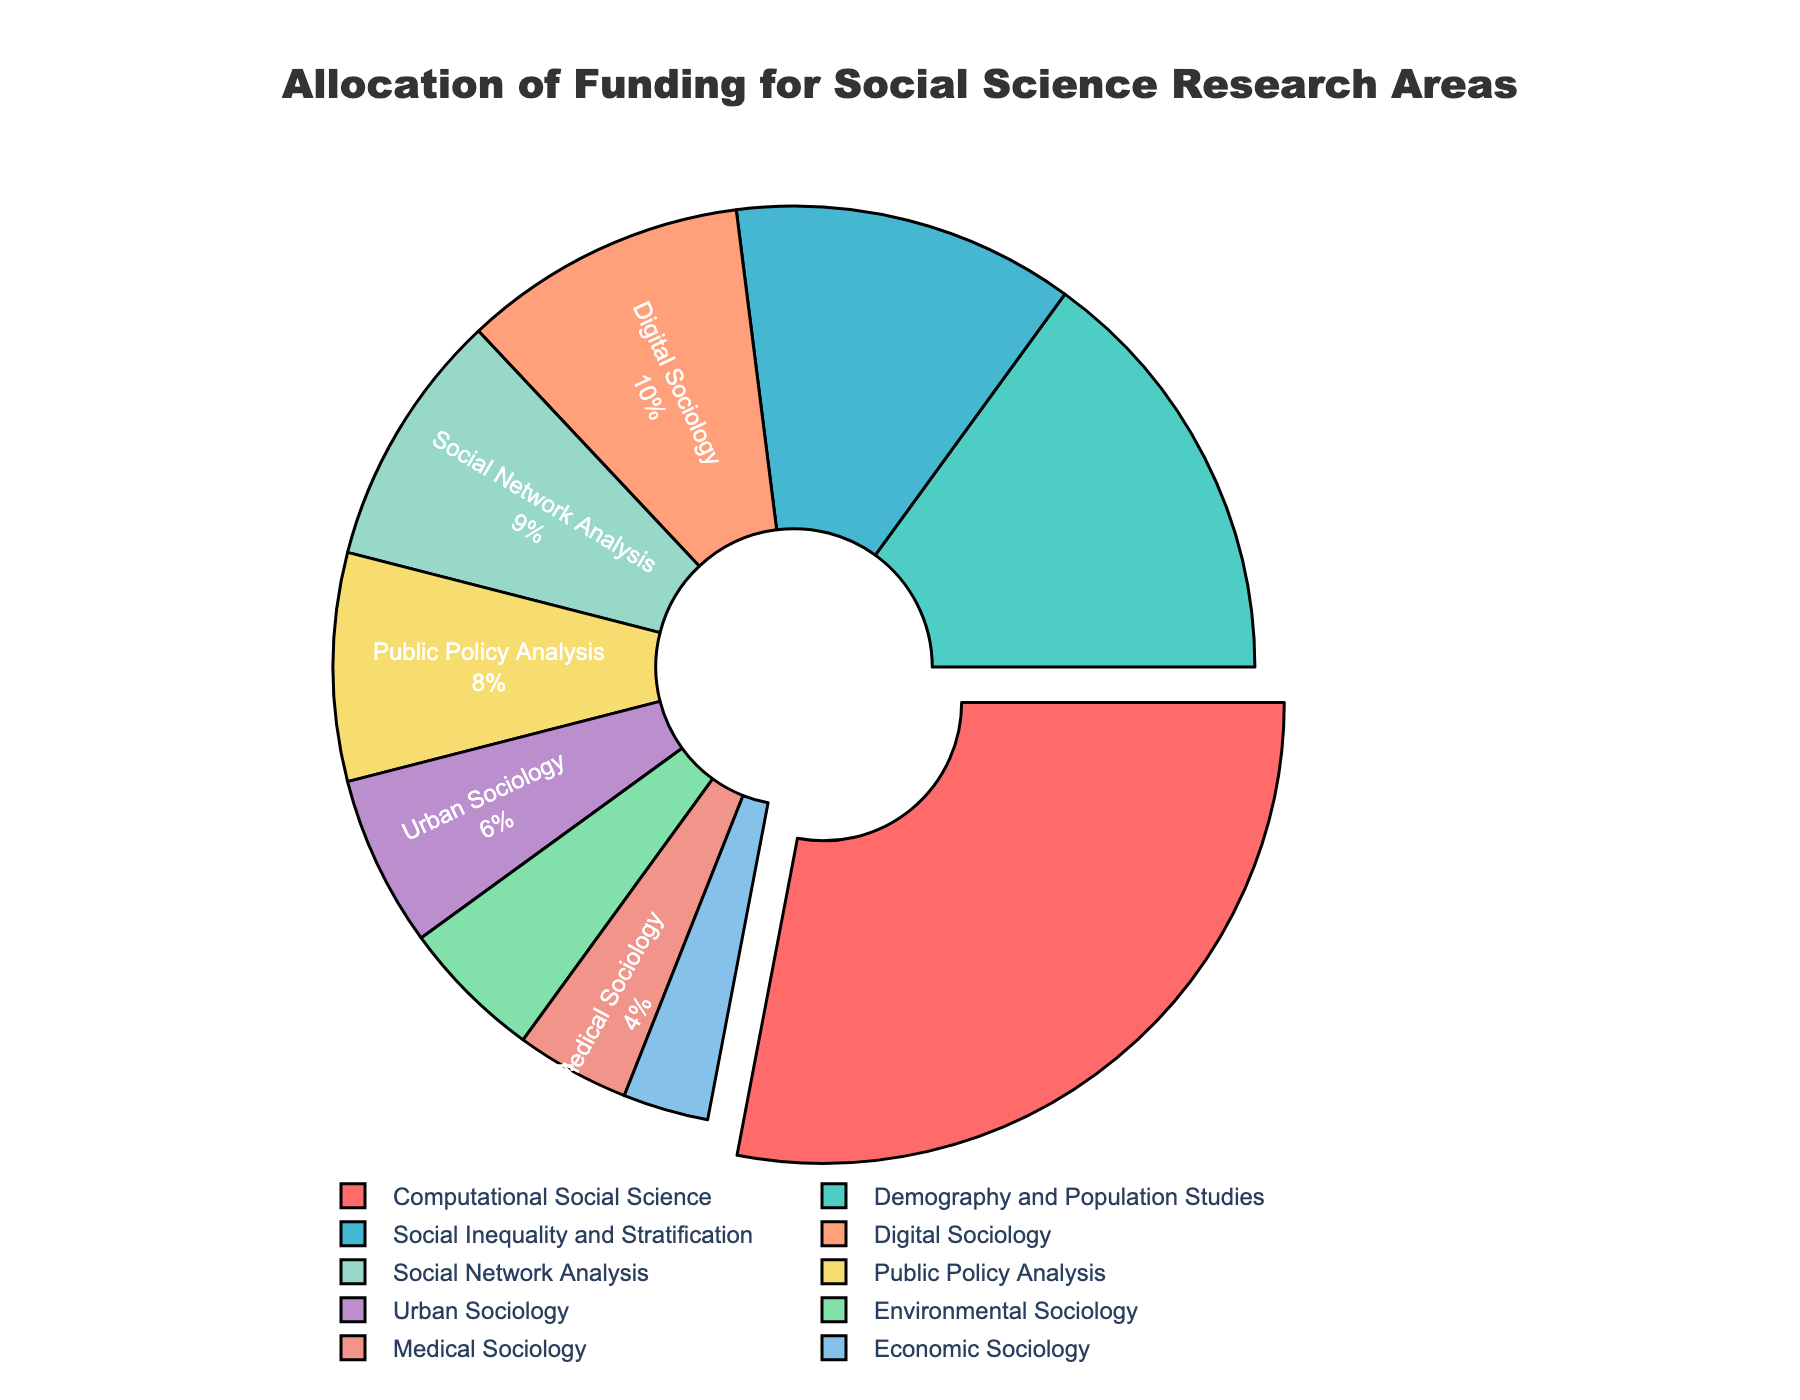What is the largest funding allocation percentage, and which research area does it belong to? The pie chart shows that the largest funding allocation, highlighted by being pulled out, goes to Computational Social Science with 28%.
Answer: Computational Social Science, 28% Which two research areas have the closest funding allocations, and what are their respective percentages? By comparing all the funding percentages, the closest are Social Network Analysis at 9% and Public Policy Analysis at 8%.
Answer: Social Network Analysis, 9% and Public Policy Analysis, 8% What is the total funding percentage allocated to the four least funded research areas? Adding the percentages of Economic Sociology (3%), Medical Sociology (4%), Environmental Sociology (5%), and Urban Sociology (6%) gives 3% + 4% + 5% + 6% = 18%.
Answer: 18% What research area is represented by the second largest slice of the pie, and what is the percentage? After Computational Social Science, Demography and Population Studies has the next largest slice with 15%.
Answer: Demography and Population Studies, 15% Compare the funding allocations for Digital Sociology and Economic Sociology. How much larger is the allocation for Digital Sociology? Digital Sociology has 10% while Economic Sociology has 3%. The difference is 10% - 3% = 7%.
Answer: 7% How much funding is allocated to the three research areas with the lowest percentages, and what are they? Summing up the percentages of Economic Sociology (3%), Medical Sociology (4%), and Environmental Sociology (5%) gives 3% + 4% + 5% = 12%.
Answer: 12% What percentage of the total funding is allocated to Social Inequality and Stratification and Public Policy Analysis combined? Adding the percentages of Social Inequality and Stratification (12%) and Public Policy Analysis (8%) gives 12% + 8% = 20%.
Answer: 20% Which research area is allocated an 8% funding, and what is its visual representation in the pie chart? Public Policy Analysis is allocated 8% funding and is represented by a yellowish segment in the pie chart.
Answer: Public Policy Analysis, yellowish segment What share of the total funding is allocated to the top three research areas? The top three research areas are Computational Social Science (28%), Demography and Population Studies (15%), and Social Inequality and Stratification (12%). Adding these gives 28% + 15% + 12% = 55%.
Answer: 55% What are the colors used for representing Social Network Analysis and Environmental Sociology? Social Network Analysis is represented by an orange segment, and Environmental Sociology by a green segment.
Answer: orange and green 